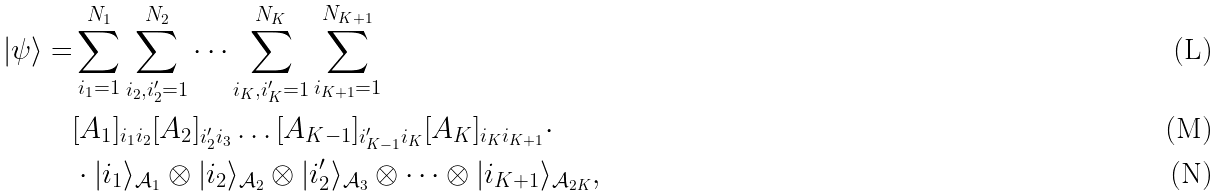<formula> <loc_0><loc_0><loc_500><loc_500>| \psi \rangle = & \sum _ { i _ { 1 } = 1 } ^ { N _ { 1 } } \sum _ { i _ { 2 } , i _ { 2 } ^ { \prime } = 1 } ^ { N _ { 2 } } \dots \sum _ { i _ { K } , i _ { K } ^ { \prime } = 1 } ^ { N _ { K } } \sum _ { i _ { K + 1 } = 1 } ^ { N _ { K + 1 } } \\ & [ A _ { 1 } ] _ { i _ { 1 } i _ { 2 } } [ A _ { 2 } ] _ { i _ { 2 } ^ { \prime } i _ { 3 } } \dots [ A _ { K - 1 } ] _ { i _ { K - 1 } ^ { \prime } i _ { K } } [ A _ { K } ] _ { i _ { K } i _ { K + 1 } } \cdot \\ & \cdot | i _ { 1 } \rangle _ { \mathcal { A } _ { 1 } } \otimes | i _ { 2 } \rangle _ { \mathcal { A } _ { 2 } } \otimes | i _ { 2 } ^ { \prime } \rangle _ { \mathcal { A } _ { 3 } } \otimes \dots \otimes | i _ { K + 1 } \rangle _ { \mathcal { A } _ { 2 K } } ,</formula> 